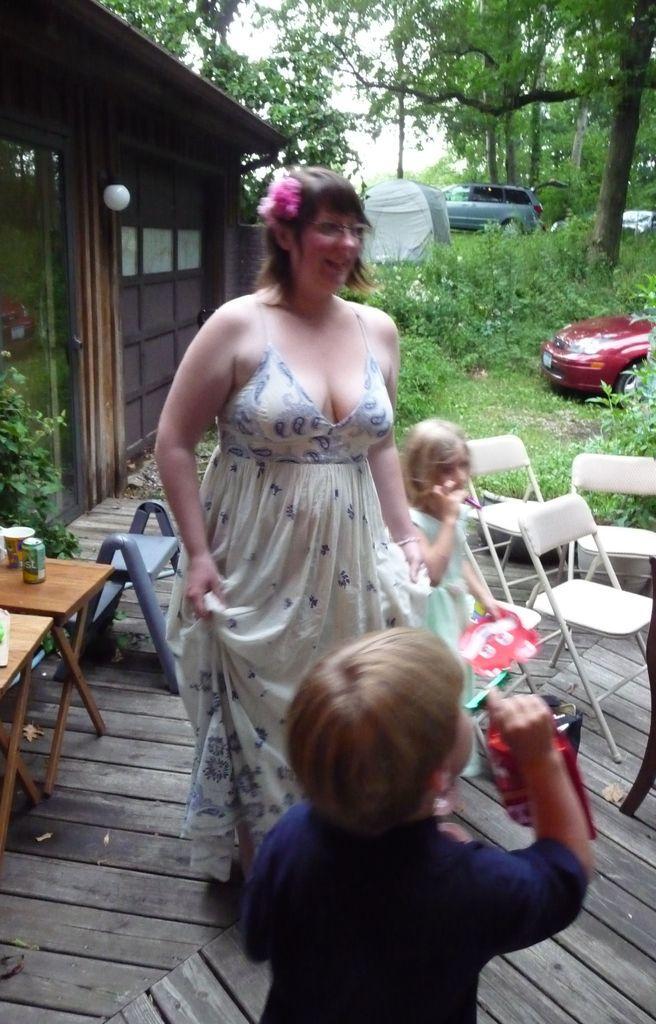Could you give a brief overview of what you see in this image? In this image I can see few people are standing. In the background I can see number of chairs, trees and few vehicles. 